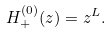Convert formula to latex. <formula><loc_0><loc_0><loc_500><loc_500>H _ { + } ^ { ( 0 ) } ( z ) = z ^ { L } .</formula> 